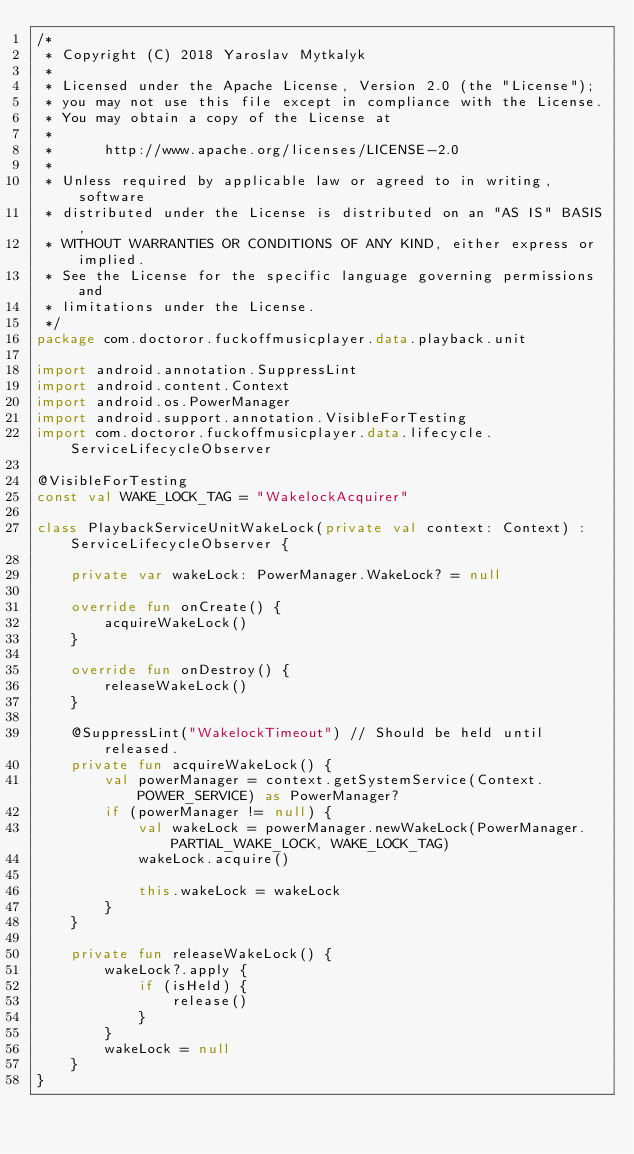<code> <loc_0><loc_0><loc_500><loc_500><_Kotlin_>/*
 * Copyright (C) 2018 Yaroslav Mytkalyk
 *
 * Licensed under the Apache License, Version 2.0 (the "License");
 * you may not use this file except in compliance with the License.
 * You may obtain a copy of the License at
 *
 *      http://www.apache.org/licenses/LICENSE-2.0
 *
 * Unless required by applicable law or agreed to in writing, software
 * distributed under the License is distributed on an "AS IS" BASIS,
 * WITHOUT WARRANTIES OR CONDITIONS OF ANY KIND, either express or implied.
 * See the License for the specific language governing permissions and
 * limitations under the License.
 */
package com.doctoror.fuckoffmusicplayer.data.playback.unit

import android.annotation.SuppressLint
import android.content.Context
import android.os.PowerManager
import android.support.annotation.VisibleForTesting
import com.doctoror.fuckoffmusicplayer.data.lifecycle.ServiceLifecycleObserver

@VisibleForTesting
const val WAKE_LOCK_TAG = "WakelockAcquirer"

class PlaybackServiceUnitWakeLock(private val context: Context) : ServiceLifecycleObserver {

    private var wakeLock: PowerManager.WakeLock? = null

    override fun onCreate() {
        acquireWakeLock()
    }

    override fun onDestroy() {
        releaseWakeLock()
    }

    @SuppressLint("WakelockTimeout") // Should be held until released.
    private fun acquireWakeLock() {
        val powerManager = context.getSystemService(Context.POWER_SERVICE) as PowerManager?
        if (powerManager != null) {
            val wakeLock = powerManager.newWakeLock(PowerManager.PARTIAL_WAKE_LOCK, WAKE_LOCK_TAG)
            wakeLock.acquire()

            this.wakeLock = wakeLock
        }
    }

    private fun releaseWakeLock() {
        wakeLock?.apply {
            if (isHeld) {
                release()
            }
        }
        wakeLock = null
    }
}
</code> 